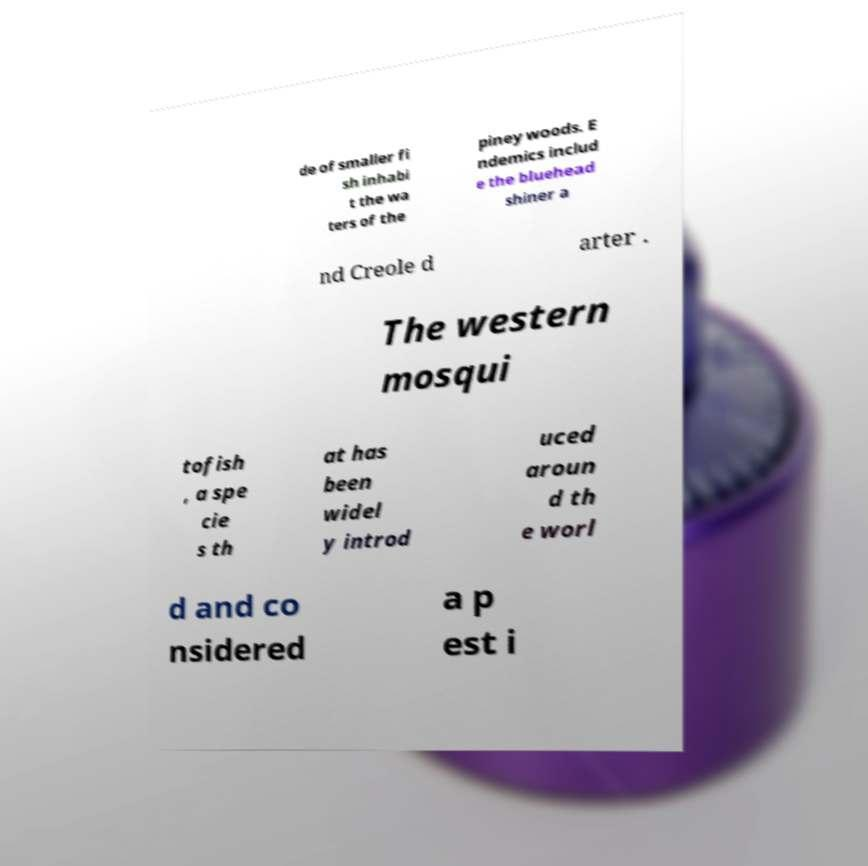Please identify and transcribe the text found in this image. de of smaller fi sh inhabi t the wa ters of the piney woods. E ndemics includ e the bluehead shiner a nd Creole d arter . The western mosqui tofish , a spe cie s th at has been widel y introd uced aroun d th e worl d and co nsidered a p est i 